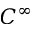Convert formula to latex. <formula><loc_0><loc_0><loc_500><loc_500>C ^ { \infty }</formula> 